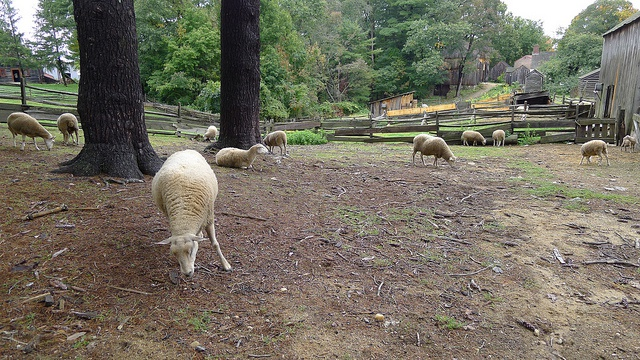Describe the objects in this image and their specific colors. I can see sheep in darkgray, lightgray, and gray tones, sheep in darkgray, gray, and black tones, sheep in darkgray, gray, black, and ivory tones, sheep in darkgray, gray, and lightgray tones, and sheep in darkgray, black, gray, and darkgreen tones in this image. 